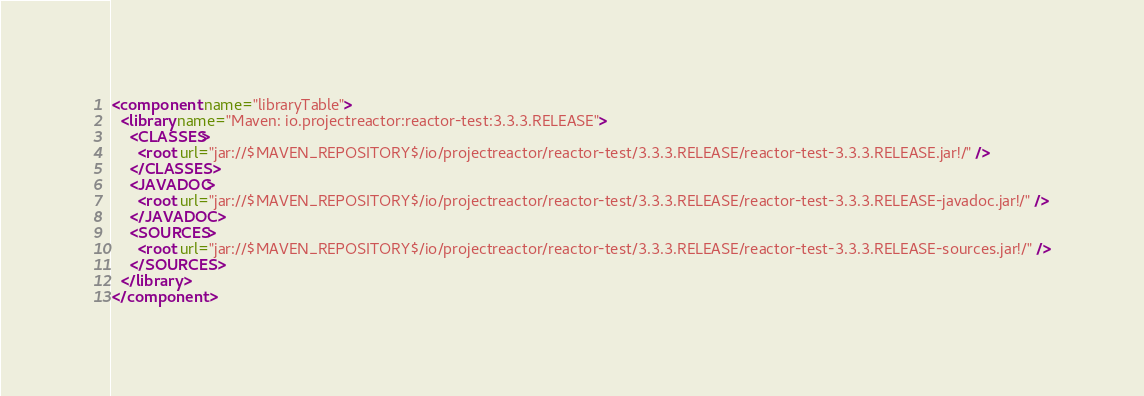<code> <loc_0><loc_0><loc_500><loc_500><_XML_><component name="libraryTable">
  <library name="Maven: io.projectreactor:reactor-test:3.3.3.RELEASE">
    <CLASSES>
      <root url="jar://$MAVEN_REPOSITORY$/io/projectreactor/reactor-test/3.3.3.RELEASE/reactor-test-3.3.3.RELEASE.jar!/" />
    </CLASSES>
    <JAVADOC>
      <root url="jar://$MAVEN_REPOSITORY$/io/projectreactor/reactor-test/3.3.3.RELEASE/reactor-test-3.3.3.RELEASE-javadoc.jar!/" />
    </JAVADOC>
    <SOURCES>
      <root url="jar://$MAVEN_REPOSITORY$/io/projectreactor/reactor-test/3.3.3.RELEASE/reactor-test-3.3.3.RELEASE-sources.jar!/" />
    </SOURCES>
  </library>
</component></code> 